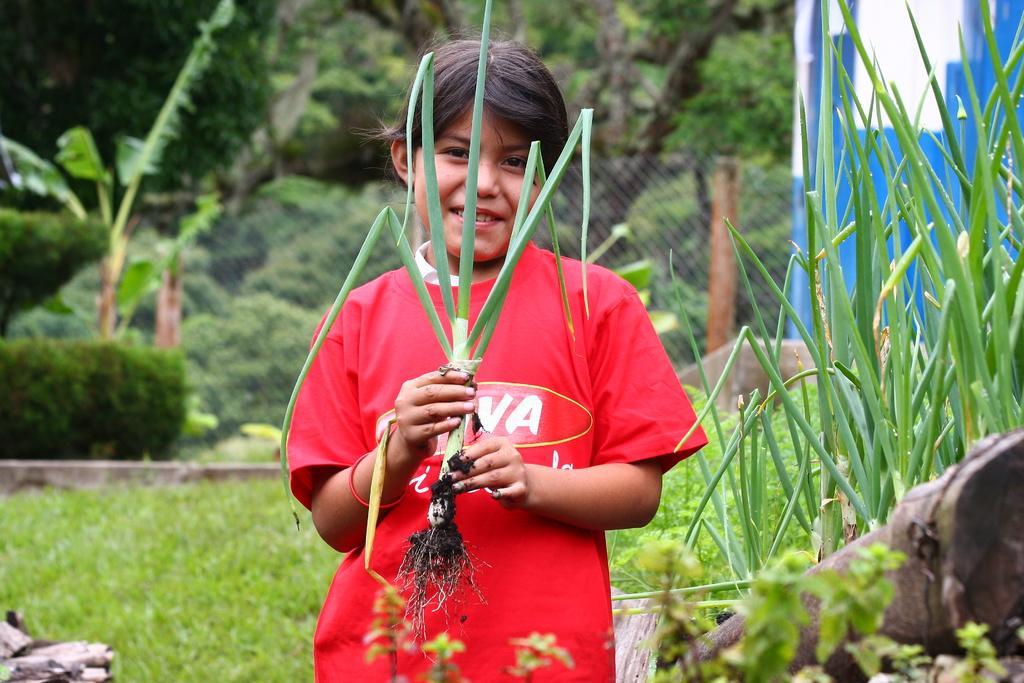How would you summarize this image in a sentence or two? In this image I can see a girl and I can see she is holding a plant. I can also see she is wearing the red colour t-shirt and on her face I can see smile. In the background I can see few more plants, grass, fencing and number of trees. On the right side of this image I can see a white and blue colour thing. 